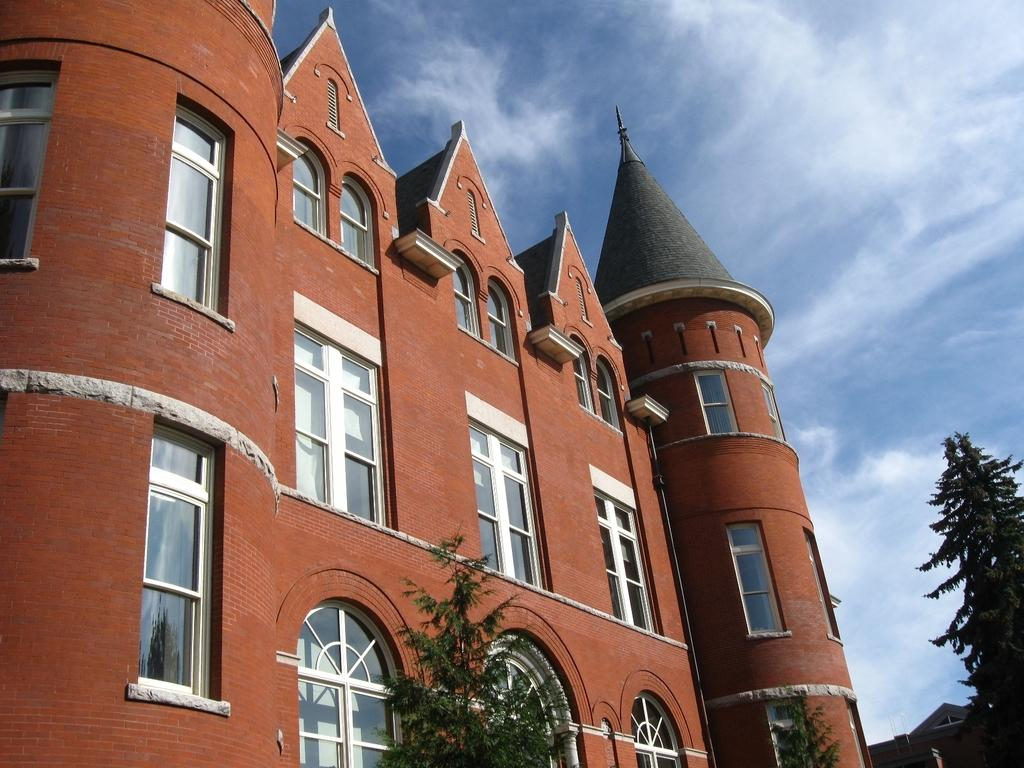What structure is located on the left side of the image? There is a building on the left side of the image. What feature can be seen on the building? The building has windows. What is attached to the wall of the building? There is a pipe on the wall of the building. What type of vegetation is visible at the bottom of the image? Trees are visible at the bottom of the image. What can be seen in the background of the image? There is a building in the background of the image. What is visible in the sky in the background of the image? Clouds are present in the sky in the background of the image. Where is the paper located in the image? There is no paper present in the image. What type of plane can be seen flying over the building in the image? There is no plane visible in the image; it only features a building, trees, and clouds. 